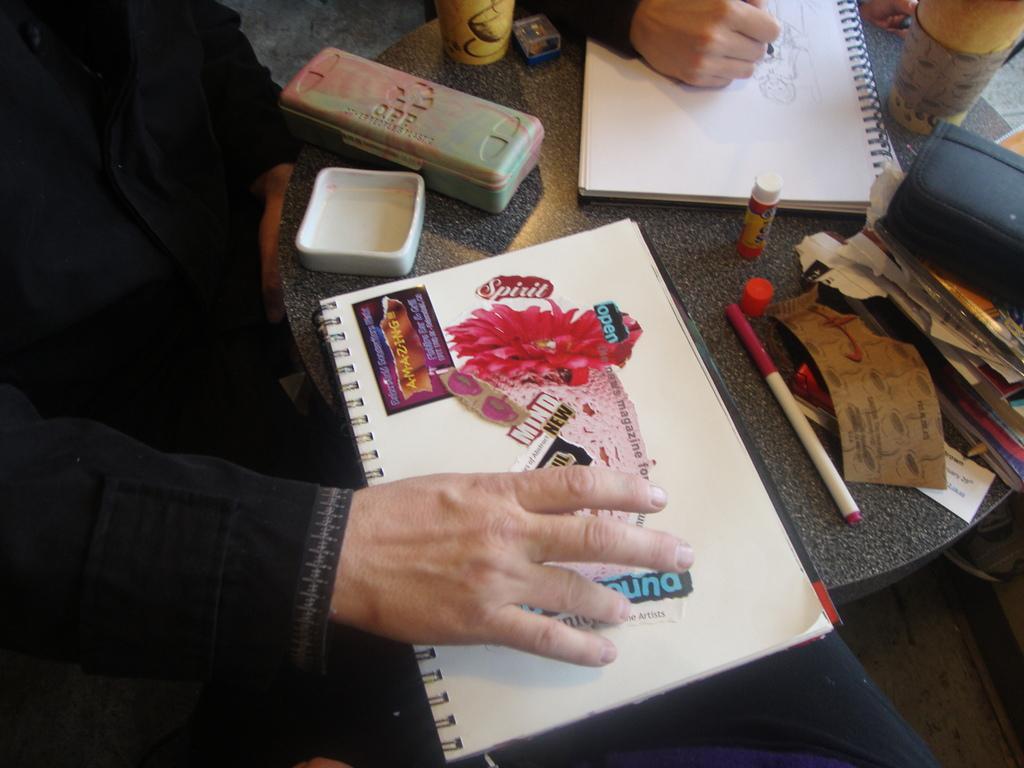Please provide a concise description of this image. In the center of the image there is a table. On the table we can see books, boxes, glasses, pen, paper, fevikwik are there. On the left side of the image we can see a person. At the top of the image a person hand is there. In the background of the image we can floor. 